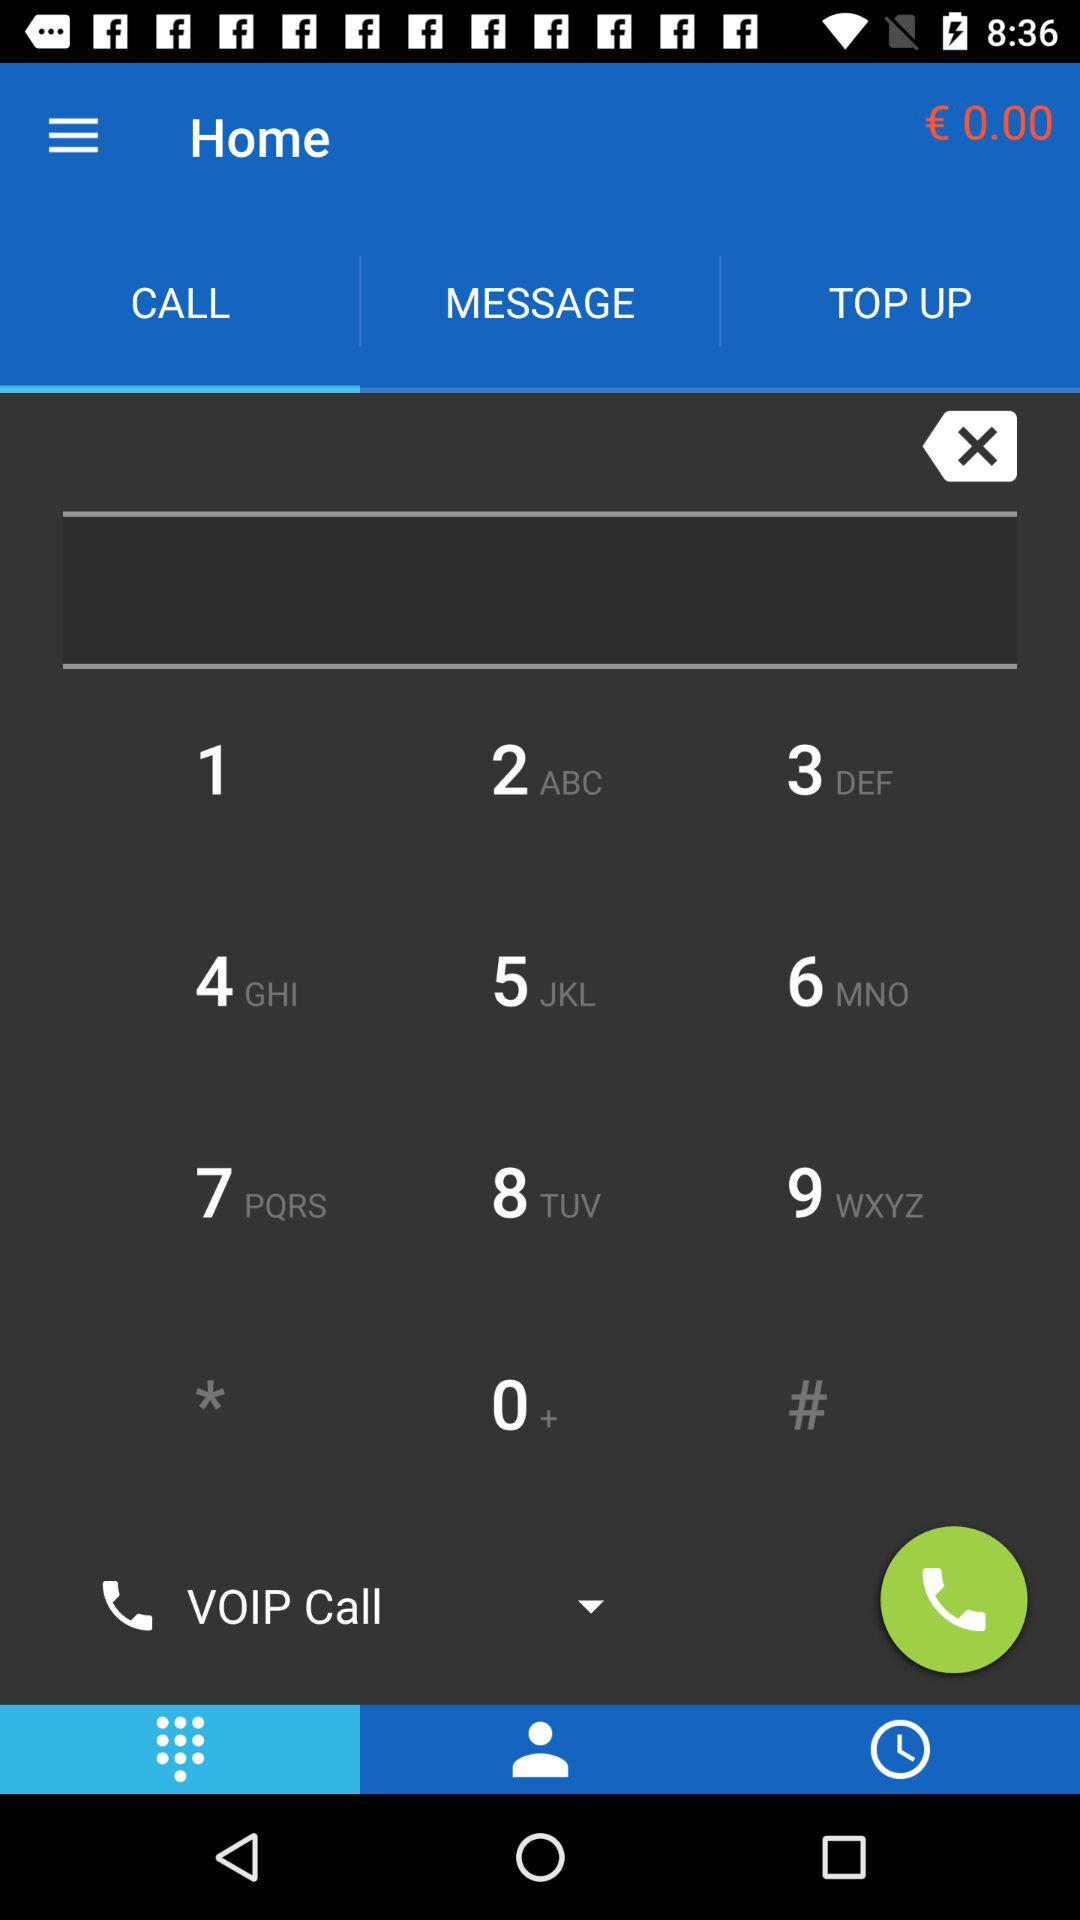How many unheard messages are there?
When the provided information is insufficient, respond with <no answer>. <no answer> 